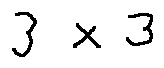<formula> <loc_0><loc_0><loc_500><loc_500>3 \times 3</formula> 